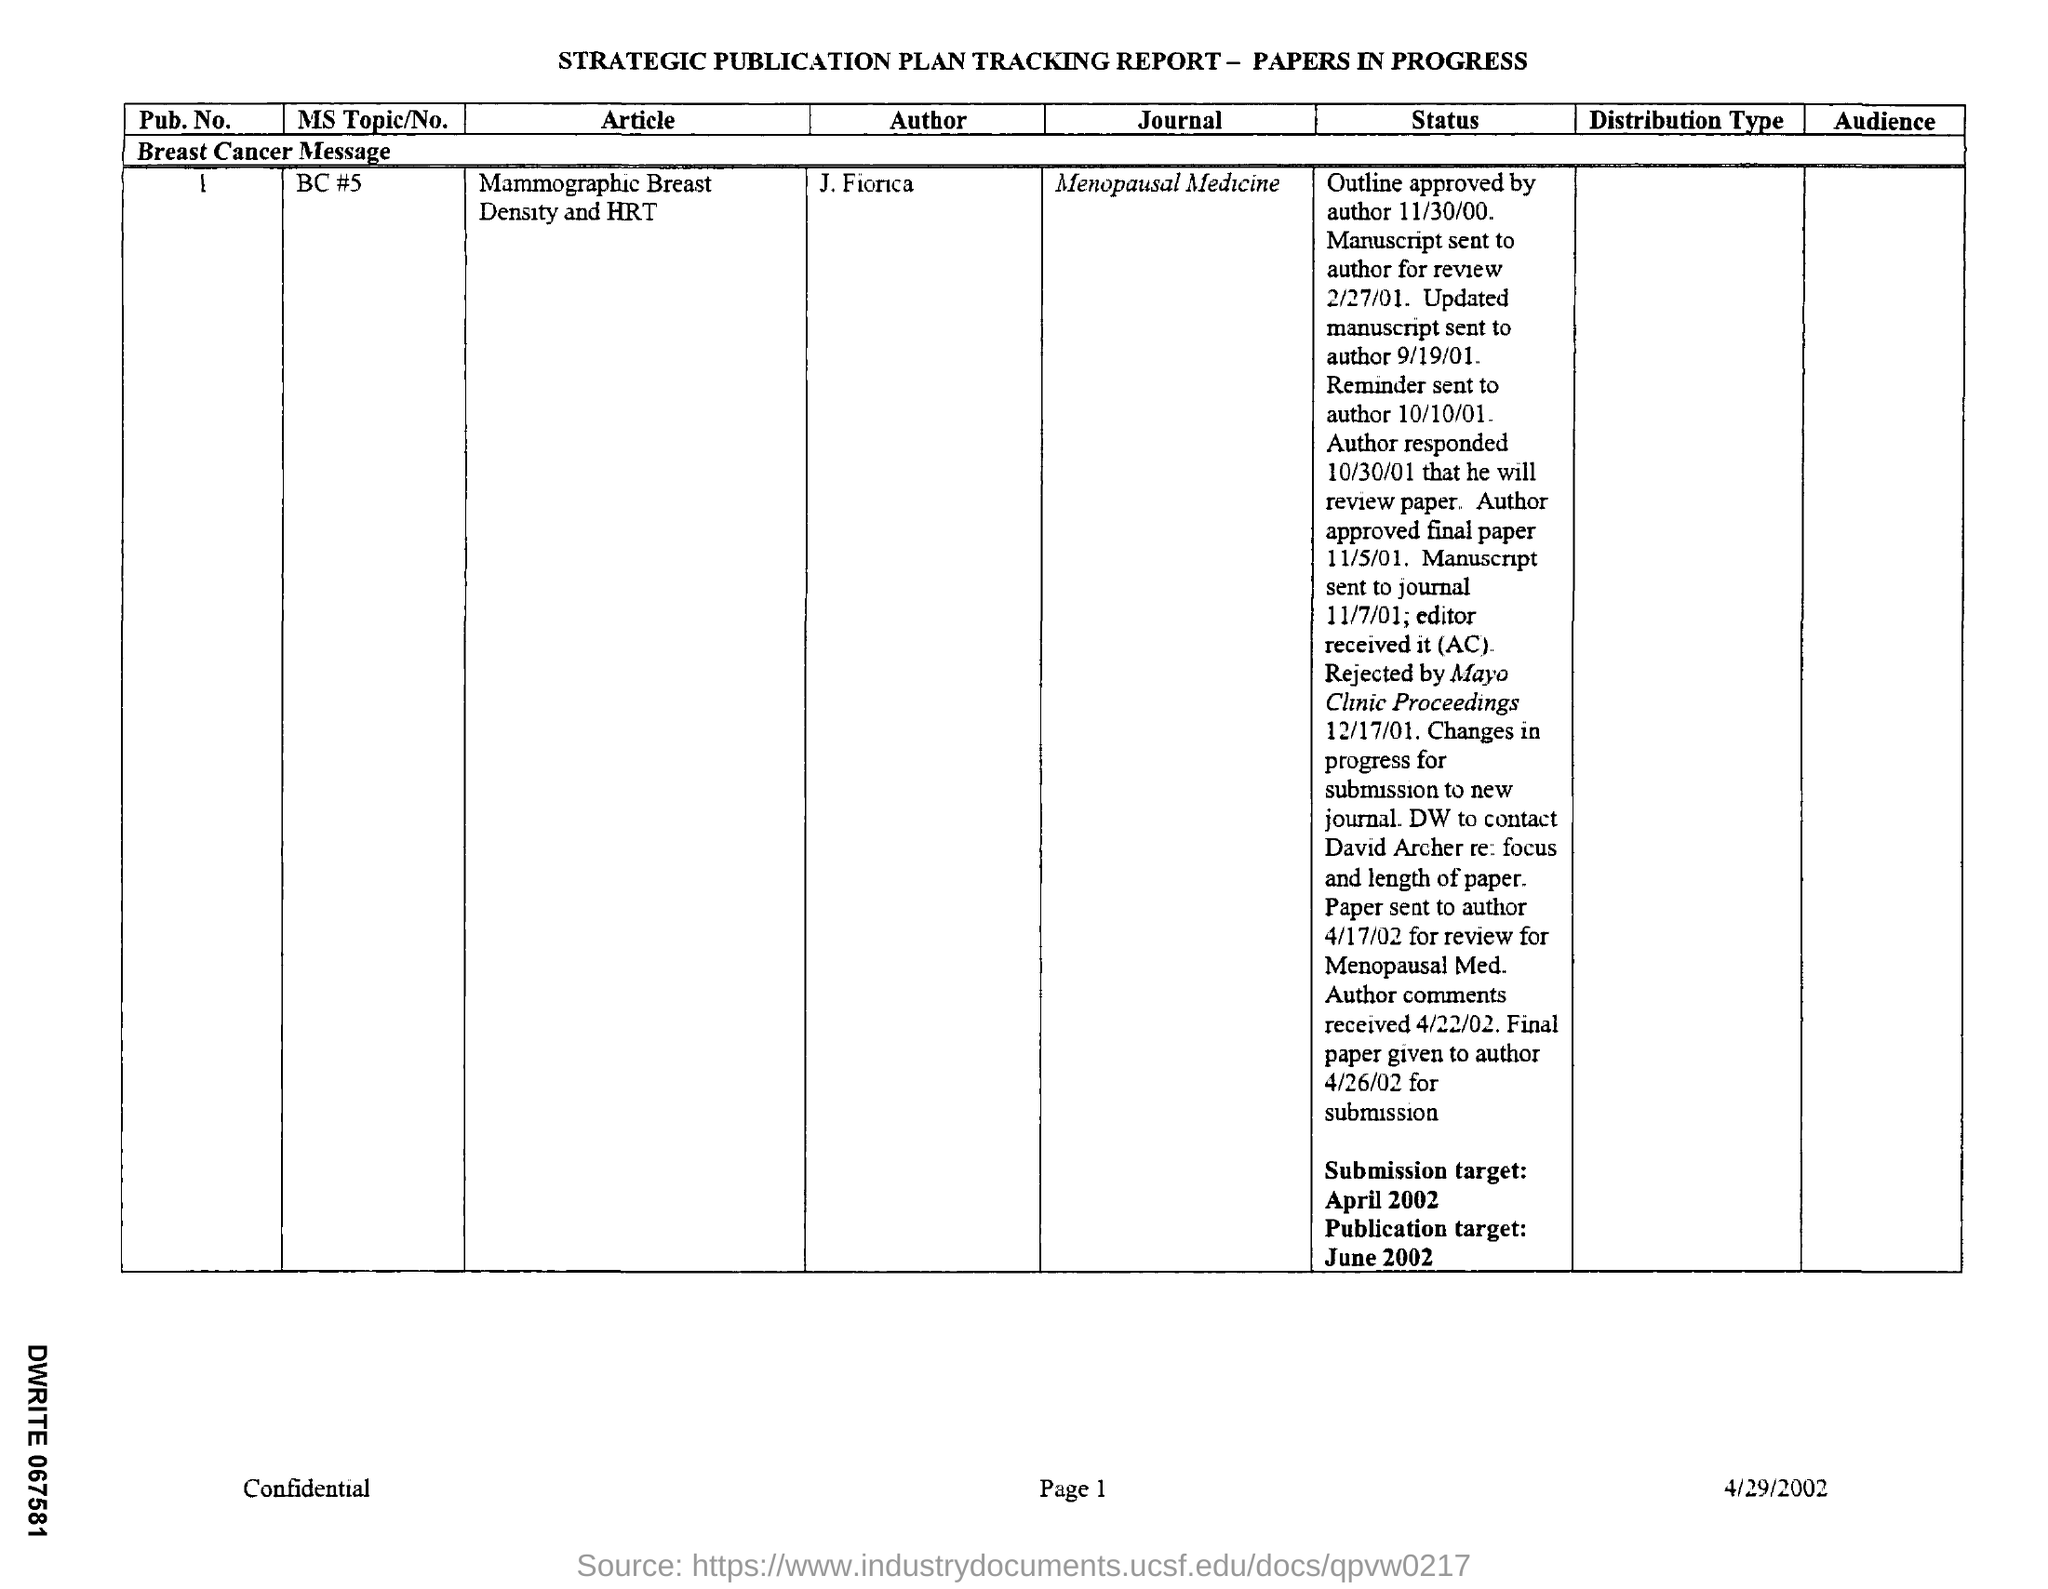Give some essential details in this illustration. The title of the article is 'Mammographic Breast Density and HRT: A Review of the Literature.' The MS Topic/No is BC #5. The name of the journal is Menopausal Medicine. The document provides information about a date that is mentioned as 4/29/2002. 